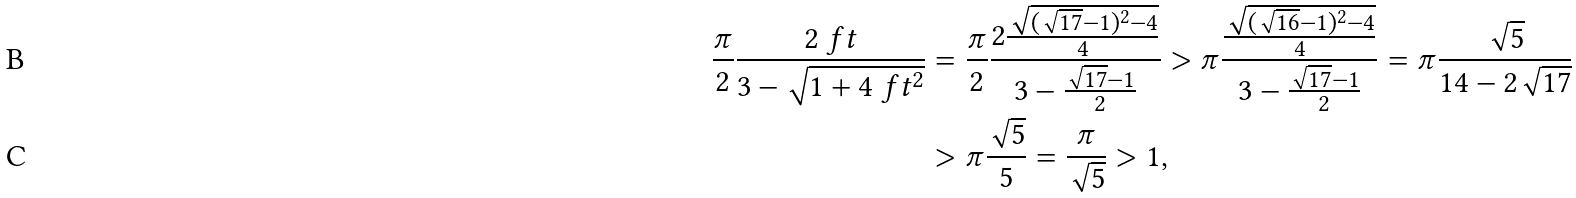Convert formula to latex. <formula><loc_0><loc_0><loc_500><loc_500>\frac { \pi } { 2 } \frac { 2 \ f t } { 3 - \sqrt { 1 + 4 \ f t ^ { 2 } } } & = \frac { \pi } { 2 } \frac { 2 \frac { \sqrt { ( \sqrt { 1 7 } - 1 ) ^ { 2 } - 4 } } { 4 } } { 3 - \frac { \sqrt { 1 7 } - 1 } { 2 } } > \pi \frac { \frac { \sqrt { ( \sqrt { 1 6 } - 1 ) ^ { 2 } - 4 } } { 4 } } { 3 - \frac { \sqrt { 1 7 } - 1 } { 2 } } = \pi \frac { \sqrt { 5 } } { 1 4 - 2 \sqrt { 1 7 } } \\ & > \pi \frac { \sqrt { 5 } } { 5 } = \frac { \pi } { \sqrt { 5 } } > 1 ,</formula> 